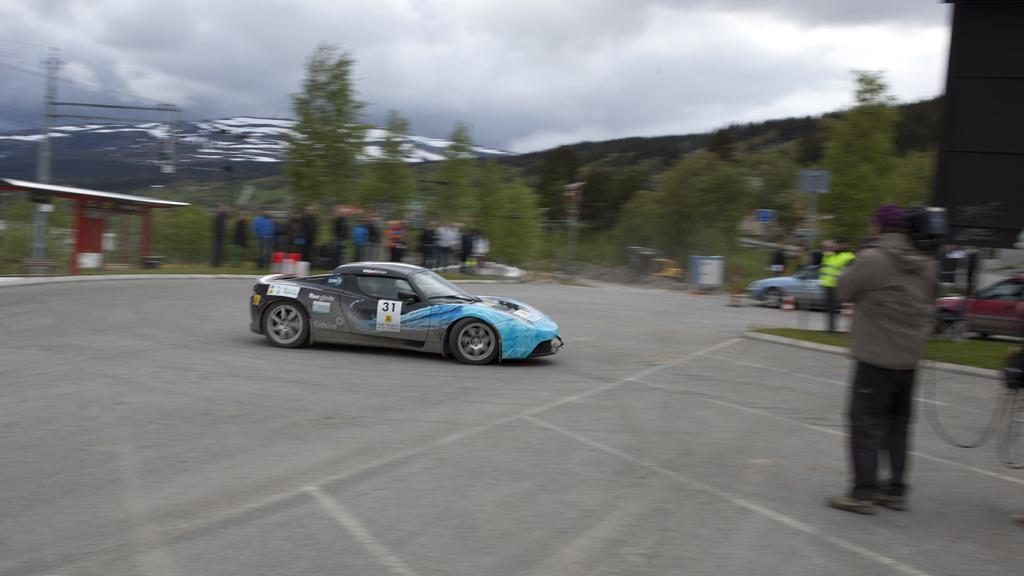What is happening in the image involving a vehicle? There is a car moving on the road in the image. What else can be seen near the road in the image? There are people standing near the road. What is visible in the background of the image? Trees and plants are visible in the background of the image. How would you describe the weather in the image? The sky is clear in the image, suggesting good weather. What advice is the person giving to the babies in the image? There are no babies present in the image, so no advice can be given. 